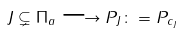Convert formula to latex. <formula><loc_0><loc_0><loc_500><loc_500>J \subsetneq \Pi _ { a } \longrightarrow P _ { J } \colon = P _ { c _ { J } }</formula> 